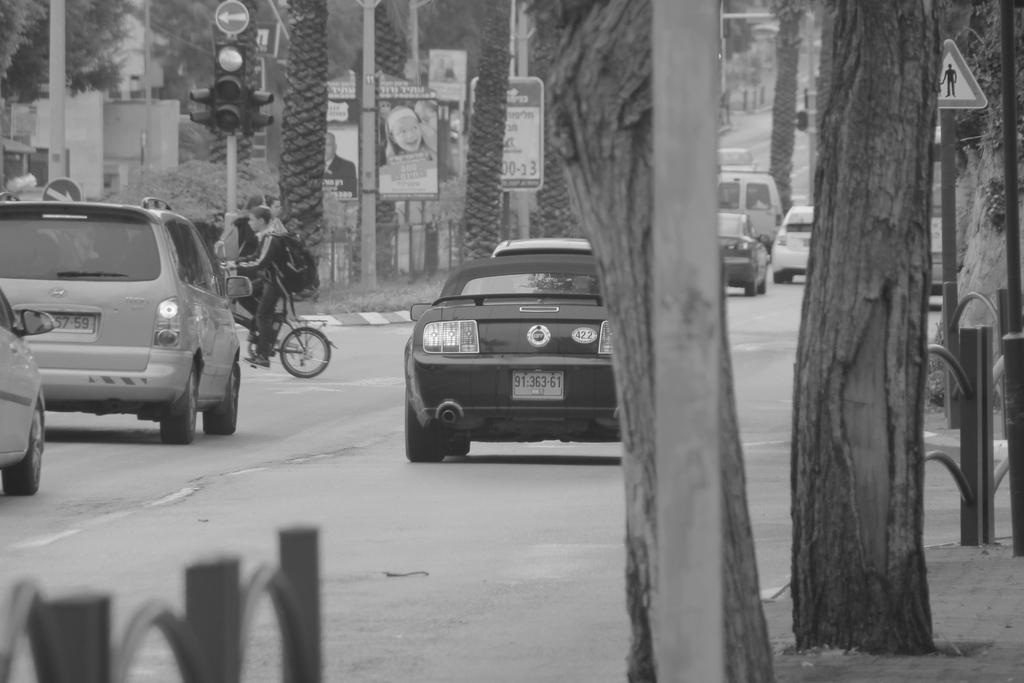What is the color scheme of the image? The image is black and white. What can be seen on the road in the image? There are vehicles on the road in the image. What type of natural elements are present in the image? There are trees in the image. What objects are present in the image that might be used for displaying information or advertisements? There are boards in the image. What safety feature can be seen in the image to regulate traffic? Signal lights are attached to poles in the image. What type of work is the tramp doing in the image? There is no tramp present in the image, so it is not possible to answer that question. 